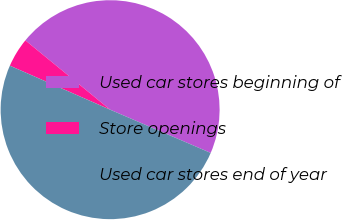Convert chart to OTSL. <chart><loc_0><loc_0><loc_500><loc_500><pie_chart><fcel>Used car stores beginning of<fcel>Store openings<fcel>Used car stores end of year<nl><fcel>45.56%<fcel>4.33%<fcel>50.12%<nl></chart> 